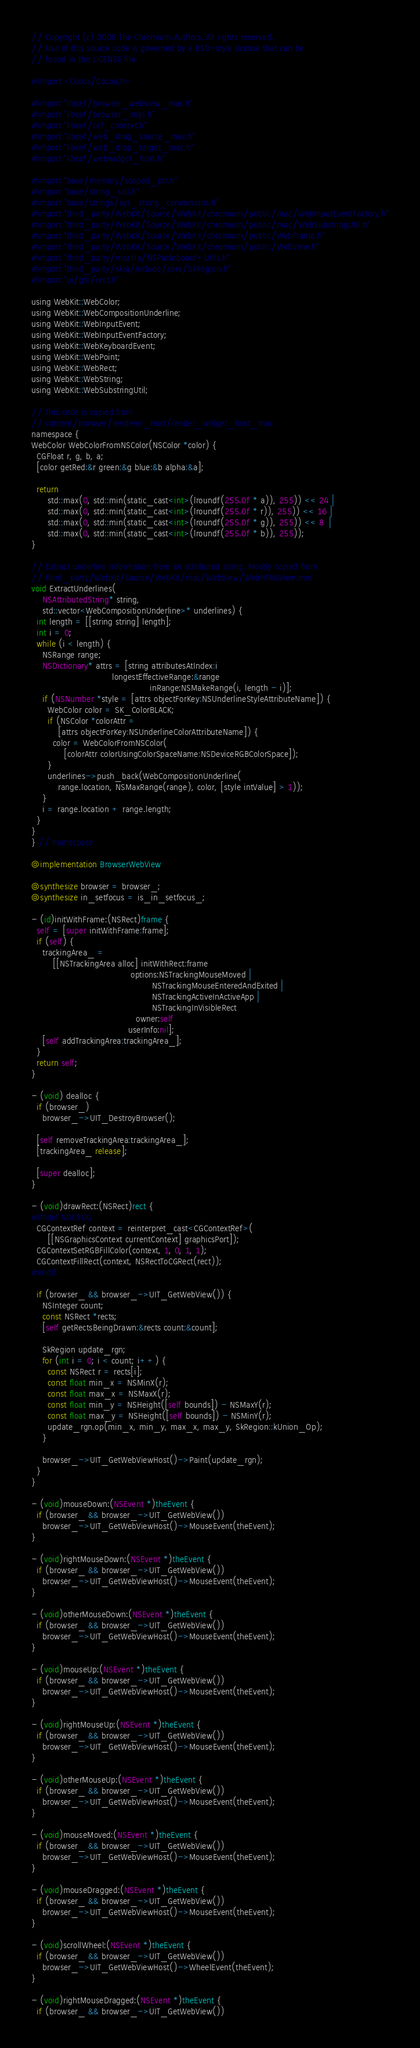Convert code to text. <code><loc_0><loc_0><loc_500><loc_500><_ObjectiveC_>// Copyright (c) 2008 The Chromium Authors. All rights reserved.
// Use of this source code is governed by a BSD-style license that can be
// found in the LICENSE file.

#import <Cocoa/Cocoa.h>

#import "libcef/browser_webview_mac.h"
#import "libcef/browser_impl.h"
#import "libcef/cef_context.h"
#import "libcef/web_drag_source_mac.h"
#import "libcef/web_drop_target_mac.h"
#import "libcef/webwidget_host.h"

#import "base/memory/scoped_ptr.h"
#import "base/string_util.h"
#import "base/strings/sys_string_conversions.h"
#import "third_party/WebKit/Source/WebKit/chromium/public/mac/WebInputEventFactory.h"
#import "third_party/WebKit/Source/WebKit/chromium/public/mac/WebSubstringUtil.h"
#import "third_party/WebKit/Source/WebKit/chromium/public/WebFrame.h"
#import "third_party/WebKit/Source/WebKit/chromium/public/WebView.h"
#import "third_party/mozilla/NSPasteboard+Utils.h"
#import "third_party/skia/include/core/SkRegion.h"
#import "ui/gfx/rect.h"

using WebKit::WebColor;
using WebKit::WebCompositionUnderline;
using WebKit::WebInputEvent;
using WebKit::WebInputEventFactory;
using WebKit::WebKeyboardEvent;
using WebKit::WebPoint;
using WebKit::WebRect;
using WebKit::WebString;
using WebKit::WebSubstringUtil;

// This code is copied from 
// content/browser/renderer_host/render_widget_host_mac
namespace {
WebColor WebColorFromNSColor(NSColor *color) {
  CGFloat r, g, b, a;
  [color getRed:&r green:&g blue:&b alpha:&a];

  return
      std::max(0, std::min(static_cast<int>(lroundf(255.0f * a)), 255)) << 24 |
      std::max(0, std::min(static_cast<int>(lroundf(255.0f * r)), 255)) << 16 |
      std::max(0, std::min(static_cast<int>(lroundf(255.0f * g)), 255)) << 8  |
      std::max(0, std::min(static_cast<int>(lroundf(255.0f * b)), 255));
}

// Extract underline information from an attributed string. Mostly copied from
// third_party/WebKit/Source/WebKit/mac/WebView/WebHTMLView.mm
void ExtractUnderlines(
    NSAttributedString* string,
    std::vector<WebCompositionUnderline>* underlines) {
  int length = [[string string] length];
  int i = 0;
  while (i < length) {
    NSRange range;
    NSDictionary* attrs = [string attributesAtIndex:i
                              longestEffectiveRange:&range
                                            inRange:NSMakeRange(i, length - i)];
    if (NSNumber *style = [attrs objectForKey:NSUnderlineStyleAttributeName]) {
      WebColor color = SK_ColorBLACK;
      if (NSColor *colorAttr =
          [attrs objectForKey:NSUnderlineColorAttributeName]) {
        color = WebColorFromNSColor(
            [colorAttr colorUsingColorSpaceName:NSDeviceRGBColorSpace]);
      }
      underlines->push_back(WebCompositionUnderline(
          range.location, NSMaxRange(range), color, [style intValue] > 1));
    }
    i = range.location + range.length;
  }
}
} // namespace

@implementation BrowserWebView

@synthesize browser = browser_;
@synthesize in_setfocus = is_in_setfocus_;

- (id)initWithFrame:(NSRect)frame {
  self = [super initWithFrame:frame];
  if (self) {
    trackingArea_ =
        [[NSTrackingArea alloc] initWithRect:frame
                                     options:NSTrackingMouseMoved |
                                             NSTrackingMouseEnteredAndExited |
                                             NSTrackingActiveInActiveApp |
                                             NSTrackingInVisibleRect
                                       owner:self
                                    userInfo:nil];
    [self addTrackingArea:trackingArea_];
  }
  return self;
}

- (void) dealloc {
  if (browser_)
    browser_->UIT_DestroyBrowser();

  [self removeTrackingArea:trackingArea_];
  [trackingArea_ release];
  
  [super dealloc];
}

- (void)drawRect:(NSRect)rect {
#ifndef NDEBUG
  CGContextRef context = reinterpret_cast<CGContextRef>(
      [[NSGraphicsContext currentContext] graphicsPort]);
  CGContextSetRGBFillColor(context, 1, 0, 1, 1);
  CGContextFillRect(context, NSRectToCGRect(rect));
#endif

  if (browser_ && browser_->UIT_GetWebView()) {
    NSInteger count;
    const NSRect *rects;
    [self getRectsBeingDrawn:&rects count:&count];

    SkRegion update_rgn;
    for (int i = 0; i < count; i++) {
      const NSRect r = rects[i];
      const float min_x = NSMinX(r);
      const float max_x = NSMaxX(r);
      const float min_y = NSHeight([self bounds]) - NSMaxY(r);
      const float max_y = NSHeight([self bounds]) - NSMinY(r);
      update_rgn.op(min_x, min_y, max_x, max_y, SkRegion::kUnion_Op);
    }

    browser_->UIT_GetWebViewHost()->Paint(update_rgn);
  }
}

- (void)mouseDown:(NSEvent *)theEvent {
  if (browser_ && browser_->UIT_GetWebView())
    browser_->UIT_GetWebViewHost()->MouseEvent(theEvent);
}

- (void)rightMouseDown:(NSEvent *)theEvent {
  if (browser_ && browser_->UIT_GetWebView())
    browser_->UIT_GetWebViewHost()->MouseEvent(theEvent);
}

- (void)otherMouseDown:(NSEvent *)theEvent {
  if (browser_ && browser_->UIT_GetWebView())
    browser_->UIT_GetWebViewHost()->MouseEvent(theEvent);
}

- (void)mouseUp:(NSEvent *)theEvent {
  if (browser_ && browser_->UIT_GetWebView())
    browser_->UIT_GetWebViewHost()->MouseEvent(theEvent);
}

- (void)rightMouseUp:(NSEvent *)theEvent {
  if (browser_ && browser_->UIT_GetWebView())
    browser_->UIT_GetWebViewHost()->MouseEvent(theEvent);
}

- (void)otherMouseUp:(NSEvent *)theEvent {
  if (browser_ && browser_->UIT_GetWebView())
    browser_->UIT_GetWebViewHost()->MouseEvent(theEvent);
}

- (void)mouseMoved:(NSEvent *)theEvent {
  if (browser_ && browser_->UIT_GetWebView())
    browser_->UIT_GetWebViewHost()->MouseEvent(theEvent);
}

- (void)mouseDragged:(NSEvent *)theEvent {
  if (browser_ && browser_->UIT_GetWebView())
    browser_->UIT_GetWebViewHost()->MouseEvent(theEvent);
}

- (void)scrollWheel:(NSEvent *)theEvent {
  if (browser_ && browser_->UIT_GetWebView())
    browser_->UIT_GetWebViewHost()->WheelEvent(theEvent);
}

- (void)rightMouseDragged:(NSEvent *)theEvent {
  if (browser_ && browser_->UIT_GetWebView())</code> 